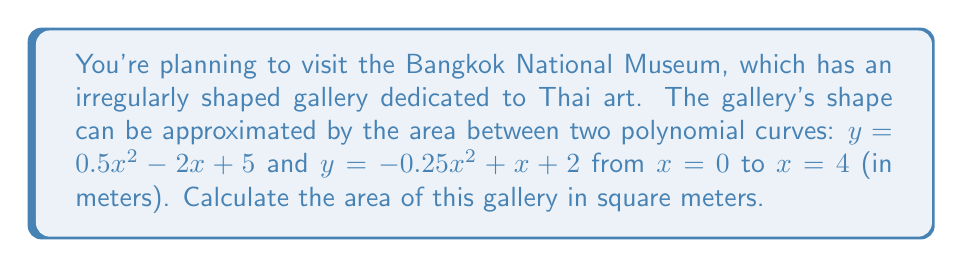Help me with this question. To find the area between two polynomial curves, we need to:

1. Find the difference between the upper and lower curves:
   $f(x) = (0.5x^2 - 2x + 5) - (-0.25x^2 + x + 2)$
   $f(x) = 0.75x^2 - 3x + 3$

2. Integrate this difference from $x = 0$ to $x = 4$:
   $$A = \int_0^4 (0.75x^2 - 3x + 3) dx$$

3. Integrate each term:
   $$A = \left[\frac{0.75x^3}{3} - \frac{3x^2}{2} + 3x\right]_0^4$$

4. Evaluate the integral:
   $$A = \left(\frac{0.75(4^3)}{3} - \frac{3(4^2)}{2} + 3(4)\right) - \left(\frac{0.75(0^3)}{3} - \frac{3(0^2)}{2} + 3(0)\right)$$
   $$A = (16 - 24 + 12) - (0 - 0 + 0)$$
   $$A = 4$$

Therefore, the area of the gallery is 4 square meters.
Answer: 4 m² 